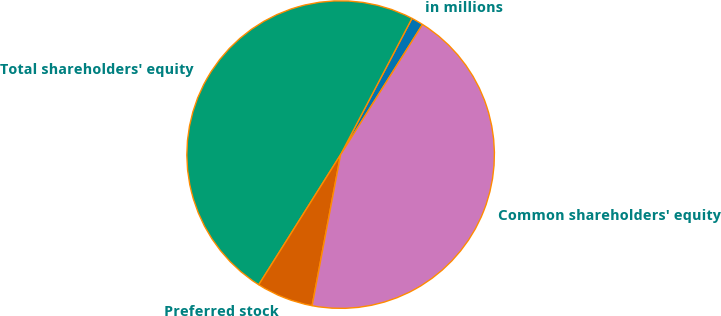Convert chart. <chart><loc_0><loc_0><loc_500><loc_500><pie_chart><fcel>in millions<fcel>Total shareholders' equity<fcel>Preferred stock<fcel>Common shareholders' equity<nl><fcel>1.26%<fcel>48.74%<fcel>5.97%<fcel>44.03%<nl></chart> 